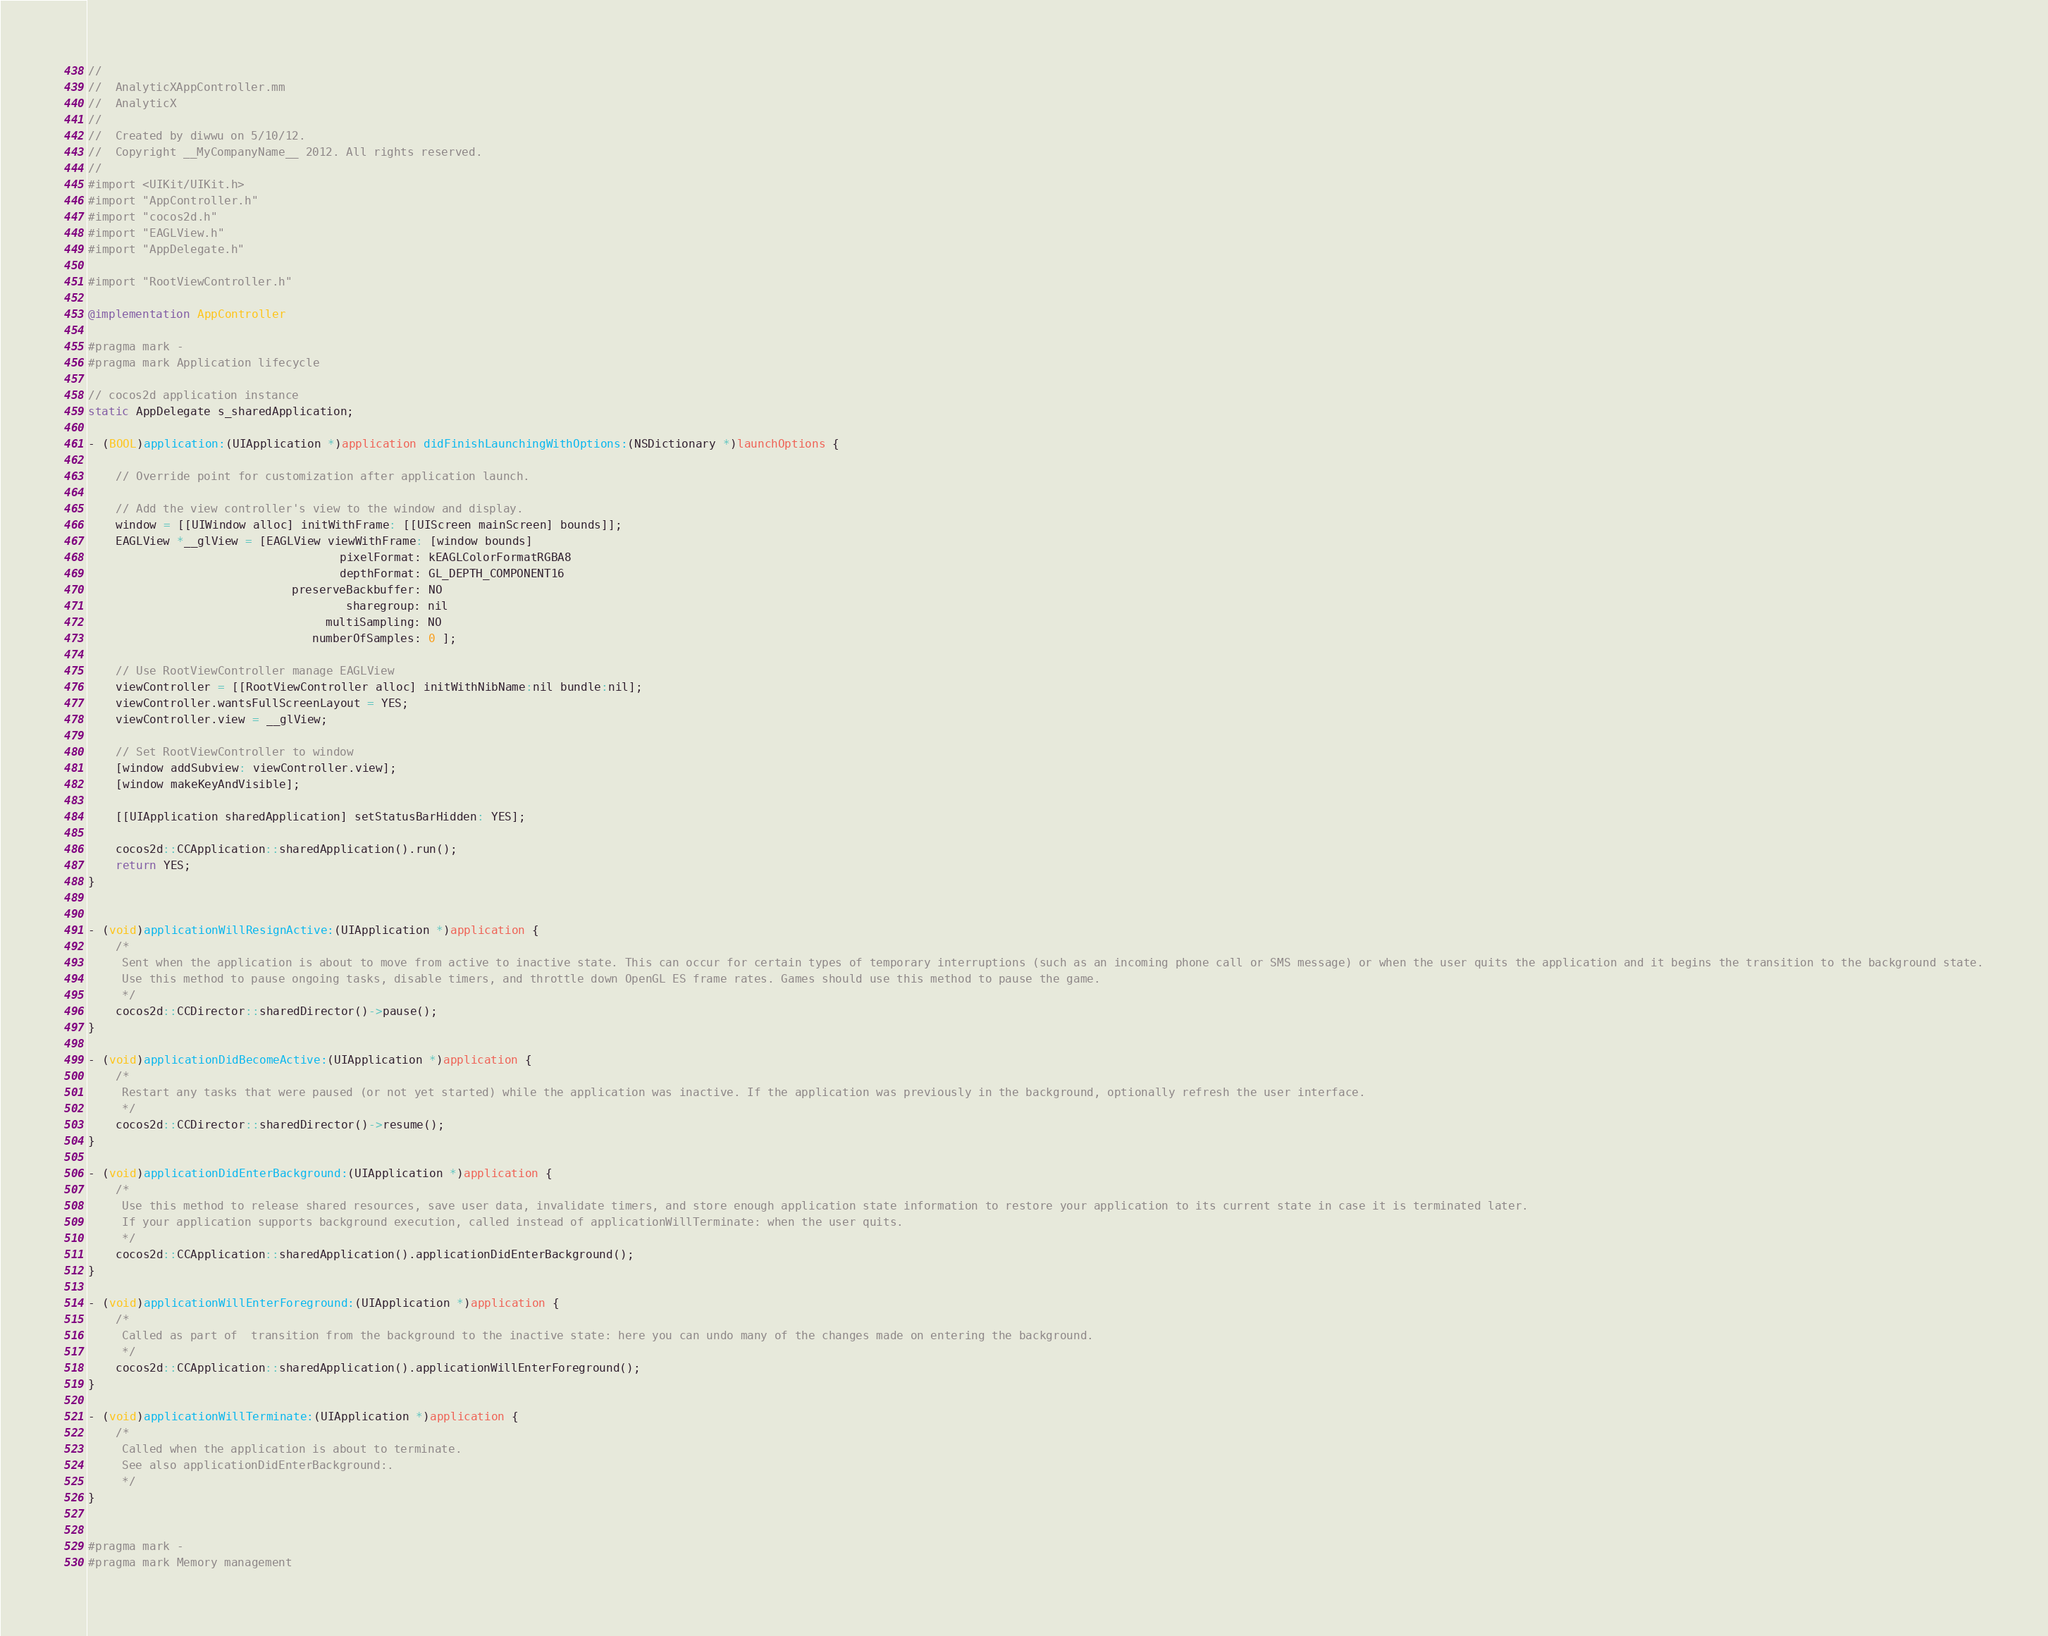Convert code to text. <code><loc_0><loc_0><loc_500><loc_500><_ObjectiveC_>//
//  AnalyticXAppController.mm
//  AnalyticX
//
//  Created by diwwu on 5/10/12.
//  Copyright __MyCompanyName__ 2012. All rights reserved.
//
#import <UIKit/UIKit.h>
#import "AppController.h"
#import "cocos2d.h"
#import "EAGLView.h"
#import "AppDelegate.h"

#import "RootViewController.h"

@implementation AppController

#pragma mark -
#pragma mark Application lifecycle

// cocos2d application instance
static AppDelegate s_sharedApplication;

- (BOOL)application:(UIApplication *)application didFinishLaunchingWithOptions:(NSDictionary *)launchOptions {

    // Override point for customization after application launch.

    // Add the view controller's view to the window and display.
    window = [[UIWindow alloc] initWithFrame: [[UIScreen mainScreen] bounds]];
    EAGLView *__glView = [EAGLView viewWithFrame: [window bounds]
                                     pixelFormat: kEAGLColorFormatRGBA8
                                     depthFormat: GL_DEPTH_COMPONENT16
                              preserveBackbuffer: NO
                                      sharegroup: nil
                                   multiSampling: NO
                                 numberOfSamples: 0 ];

    // Use RootViewController manage EAGLView
    viewController = [[RootViewController alloc] initWithNibName:nil bundle:nil];
    viewController.wantsFullScreenLayout = YES;
    viewController.view = __glView;

    // Set RootViewController to window
    [window addSubview: viewController.view];
    [window makeKeyAndVisible];

    [[UIApplication sharedApplication] setStatusBarHidden: YES];

    cocos2d::CCApplication::sharedApplication().run();
    return YES;
}


- (void)applicationWillResignActive:(UIApplication *)application {
    /*
     Sent when the application is about to move from active to inactive state. This can occur for certain types of temporary interruptions (such as an incoming phone call or SMS message) or when the user quits the application and it begins the transition to the background state.
     Use this method to pause ongoing tasks, disable timers, and throttle down OpenGL ES frame rates. Games should use this method to pause the game.
     */
    cocos2d::CCDirector::sharedDirector()->pause();
}

- (void)applicationDidBecomeActive:(UIApplication *)application {
    /*
     Restart any tasks that were paused (or not yet started) while the application was inactive. If the application was previously in the background, optionally refresh the user interface.
     */
    cocos2d::CCDirector::sharedDirector()->resume();
}

- (void)applicationDidEnterBackground:(UIApplication *)application {
    /*
     Use this method to release shared resources, save user data, invalidate timers, and store enough application state information to restore your application to its current state in case it is terminated later.
     If your application supports background execution, called instead of applicationWillTerminate: when the user quits.
     */
    cocos2d::CCApplication::sharedApplication().applicationDidEnterBackground();
}

- (void)applicationWillEnterForeground:(UIApplication *)application {
    /*
     Called as part of  transition from the background to the inactive state: here you can undo many of the changes made on entering the background.
     */
    cocos2d::CCApplication::sharedApplication().applicationWillEnterForeground();
}

- (void)applicationWillTerminate:(UIApplication *)application {
    /*
     Called when the application is about to terminate.
     See also applicationDidEnterBackground:.
     */
}


#pragma mark -
#pragma mark Memory management
</code> 